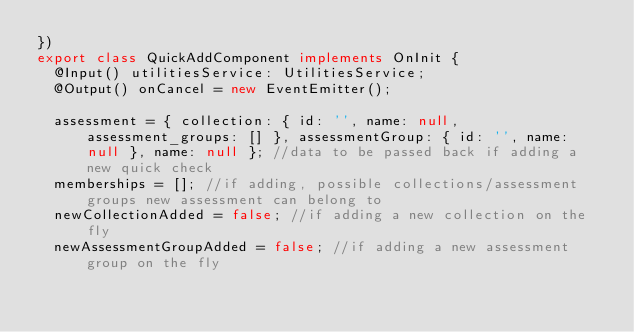Convert code to text. <code><loc_0><loc_0><loc_500><loc_500><_TypeScript_>})
export class QuickAddComponent implements OnInit {
  @Input() utilitiesService: UtilitiesService;
  @Output() onCancel = new EventEmitter();

  assessment = { collection: { id: '', name: null, assessment_groups: [] }, assessmentGroup: { id: '', name: null }, name: null }; //data to be passed back if adding a new quick check
  memberships = []; //if adding, possible collections/assessment groups new assessment can belong to
  newCollectionAdded = false; //if adding a new collection on the fly
  newAssessmentGroupAdded = false; //if adding a new assessment group on the fly</code> 